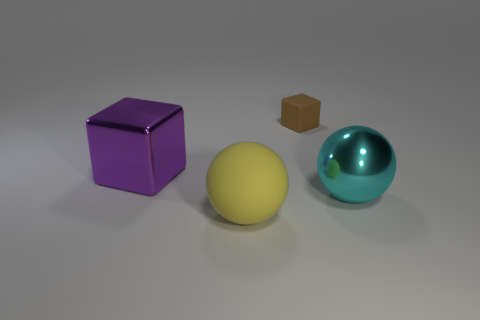Add 4 rubber spheres. How many objects exist? 8 Subtract all blue rubber cylinders. Subtract all yellow rubber objects. How many objects are left? 3 Add 2 metallic balls. How many metallic balls are left? 3 Add 2 small purple cubes. How many small purple cubes exist? 2 Subtract 0 blue cylinders. How many objects are left? 4 